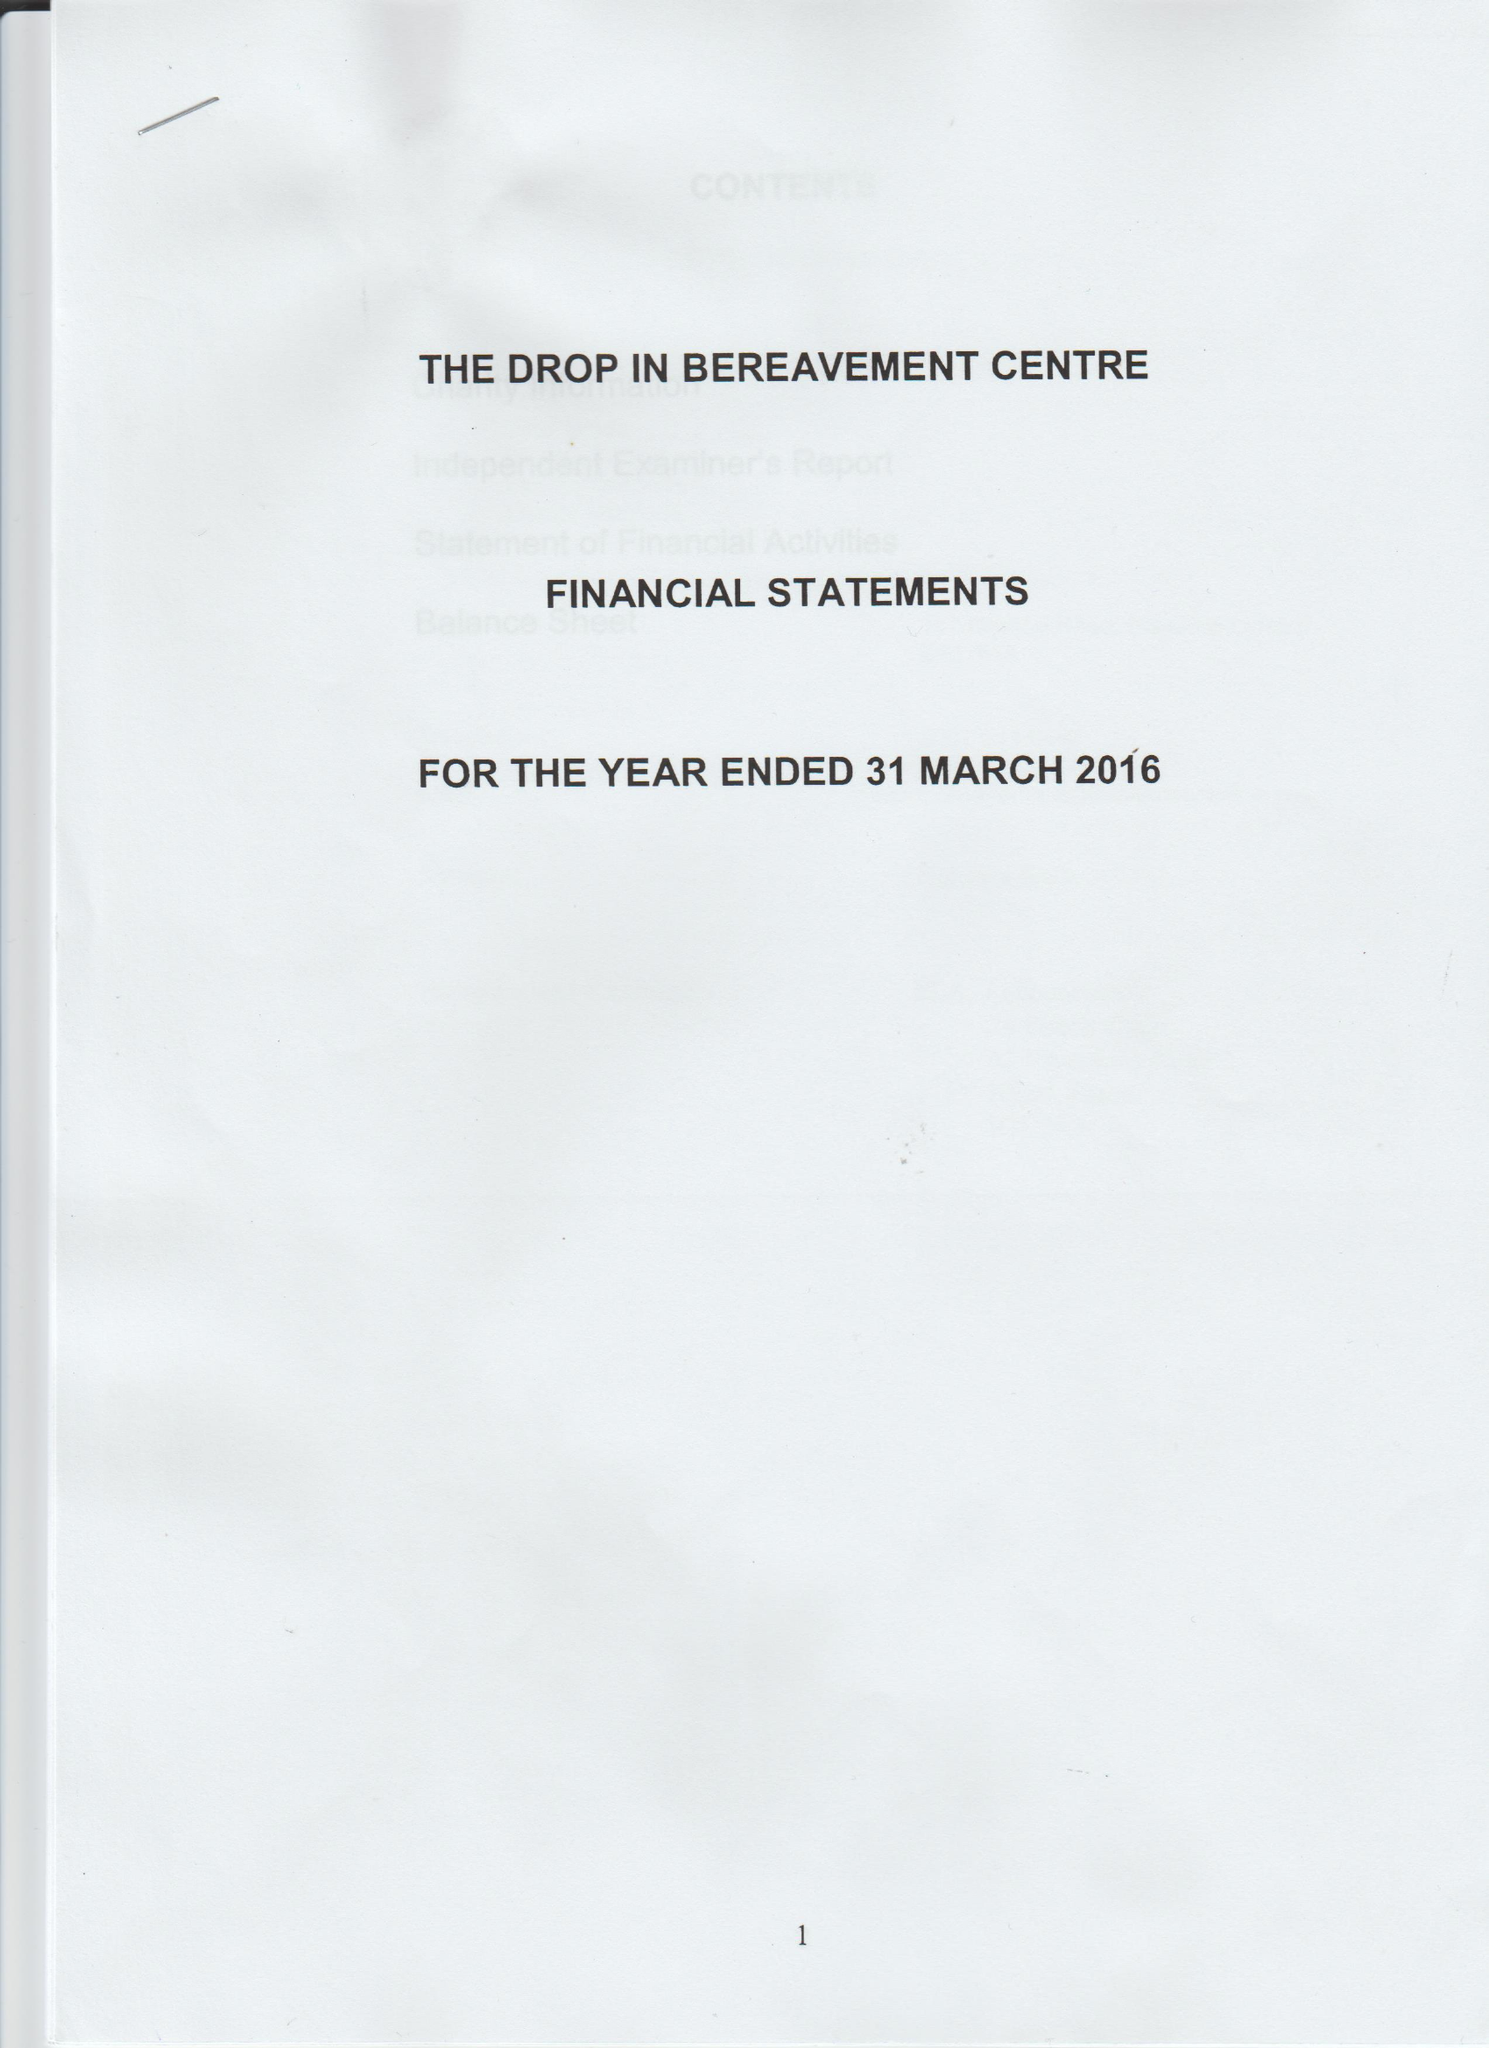What is the value for the address__post_town?
Answer the question using a single word or phrase. LONDON 